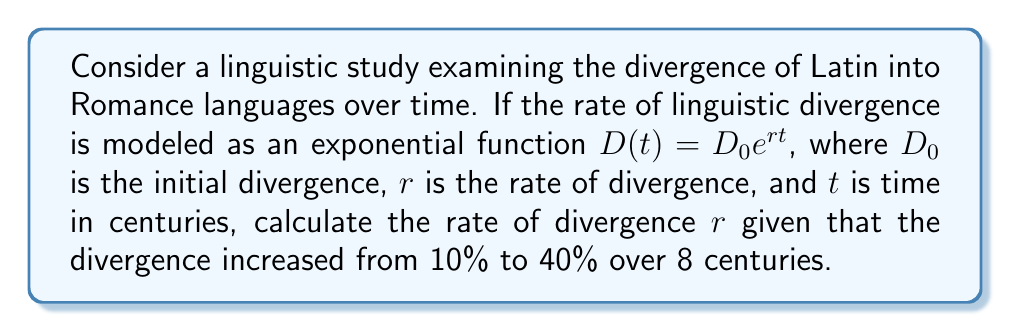Teach me how to tackle this problem. To solve this problem, we'll use the exponential growth formula and the given information:

1. Initial divergence $D_0 = 10\% = 0.1$
2. Final divergence $D(8) = 40\% = 0.4$
3. Time interval $t = 8$ centuries

We can set up the equation:

$$D(t) = D_0e^{rt}$$

Substituting the values:

$$0.4 = 0.1e^{8r}$$

Now, let's solve for $r$:

1. Divide both sides by 0.1:
   $$4 = e^{8r}$$

2. Take the natural logarithm of both sides:
   $$\ln(4) = 8r$$

3. Solve for $r$:
   $$r = \frac{\ln(4)}{8}$$

4. Calculate the value:
   $$r = \frac{\ln(4)}{8} \approx 0.1733$$

Thus, the rate of linguistic divergence is approximately 0.1733 per century.
Answer: $r \approx 0.1733$ per century 